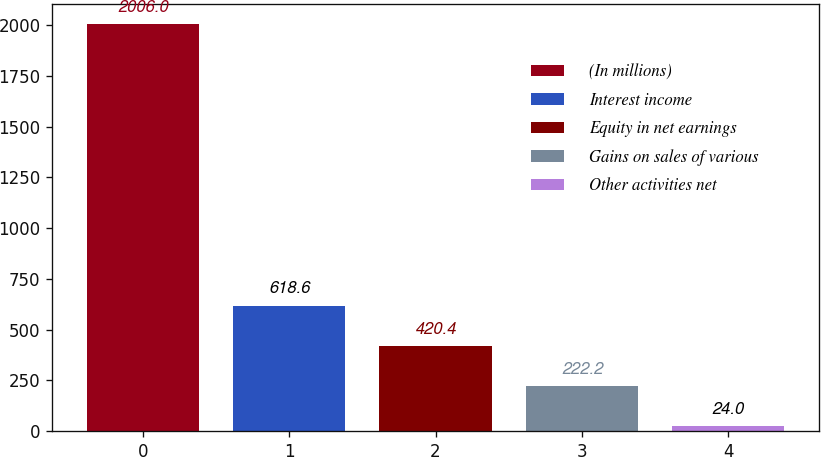Convert chart. <chart><loc_0><loc_0><loc_500><loc_500><bar_chart><fcel>(In millions)<fcel>Interest income<fcel>Equity in net earnings<fcel>Gains on sales of various<fcel>Other activities net<nl><fcel>2006<fcel>618.6<fcel>420.4<fcel>222.2<fcel>24<nl></chart> 